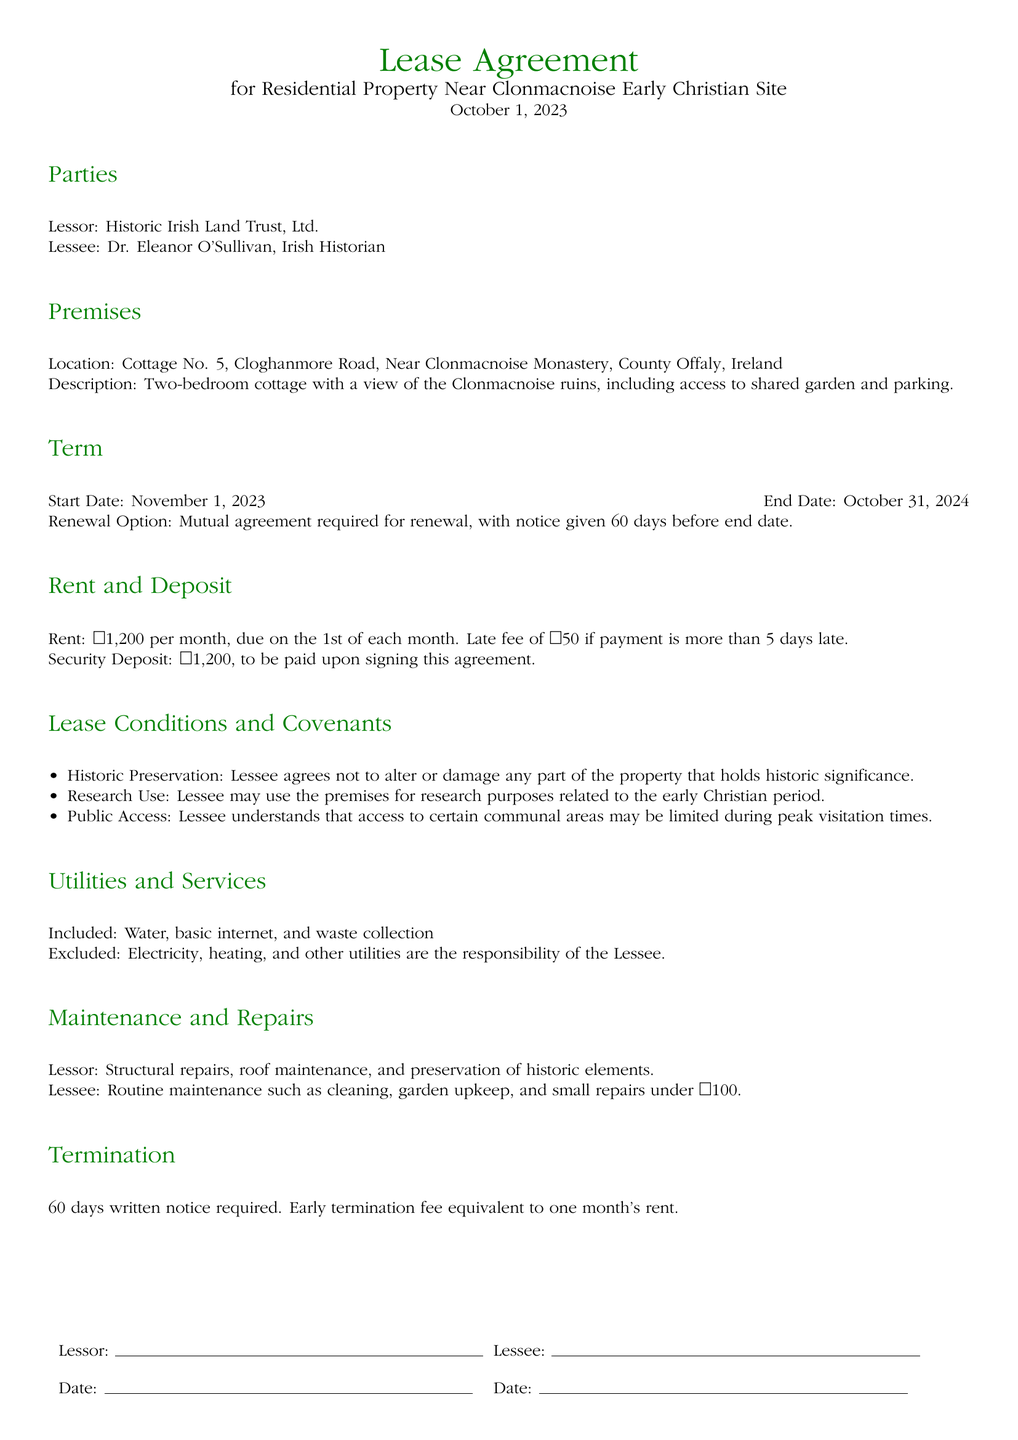What is the rent amount per month? The rent amount is explicitly stated in the lease agreement as €1,200 per month.
Answer: €1,200 Who is the Lessee? The Lessee is identified in the document as Dr. Eleanor O'Sullivan, an Irish Historian.
Answer: Dr. Eleanor O'Sullivan What is the location of the property? The lease agreement specifies that the property is located at Cottage No. 5, Cloghanmore Road, Near Clonmacnoise Monastery, County Offaly, Ireland.
Answer: Cottage No. 5, Cloghanmore Road What is the duration of the lease term? The lease term is indicated by the start and end dates, spanning from November 1, 2023, to October 31, 2024.
Answer: One year What is required for lease renewal? The document states that a mutual agreement is required for renewal, with specific notice timing mentioned.
Answer: Mutual agreement What is the early termination fee? The early termination fee is described in the document, indicating it corresponds to one month's rent.
Answer: One month's rent What utilities are excluded from the lease? The lease specifies that electricity, heating, and other utilities are the responsibility of the Lessee and thus are excluded.
Answer: Electricity and heating What kind of maintenance is the Lessee responsible for? The lease outlines that the Lessee is responsible for routine maintenance including cleaning and small repairs under €100.
Answer: Routine maintenance What is the security deposit amount? The security deposit amount is clearly mentioned in the agreement as payable upon signing.
Answer: €1,200 